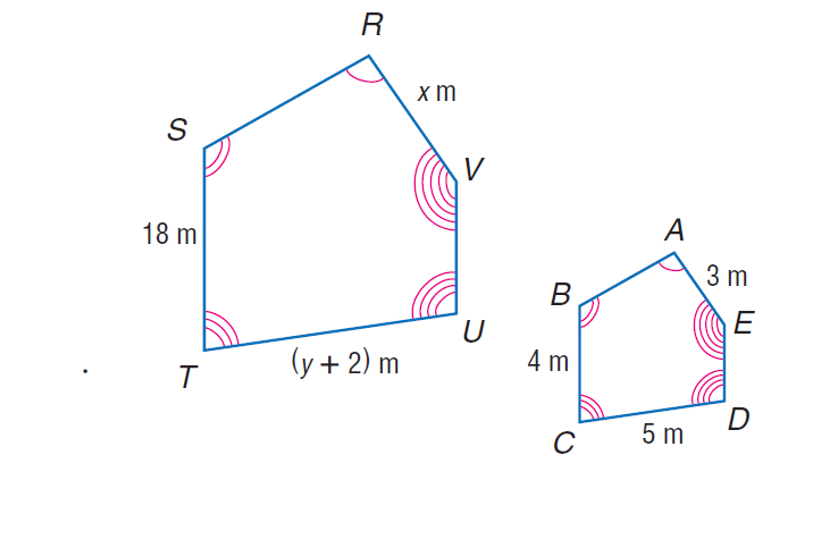Question: The two polygons are similar. Find x.
Choices:
A. 13.5
B. 18
C. 45
D. 200
Answer with the letter. Answer: A Question: The two polygons are similar. Then, find y.
Choices:
A. 18
B. 20.5
C. 38
D. 199
Answer with the letter. Answer: B 